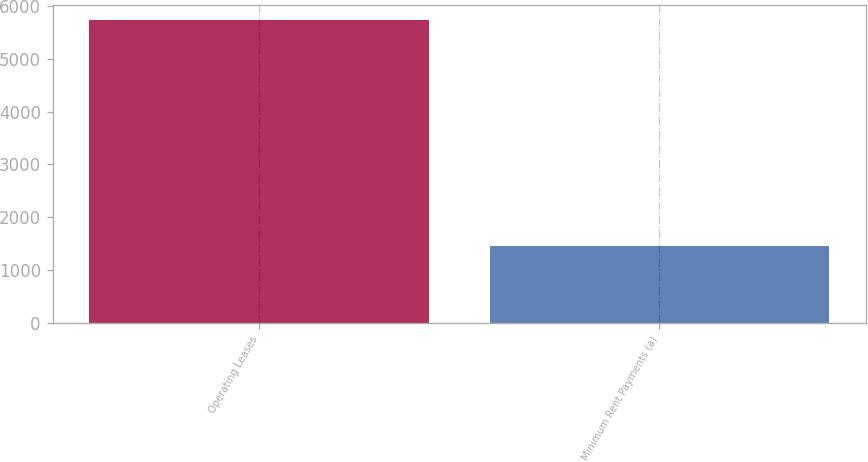<chart> <loc_0><loc_0><loc_500><loc_500><bar_chart><fcel>Operating Leases<fcel>Minimum Rent Payments (a)<nl><fcel>5733<fcel>1454<nl></chart> 